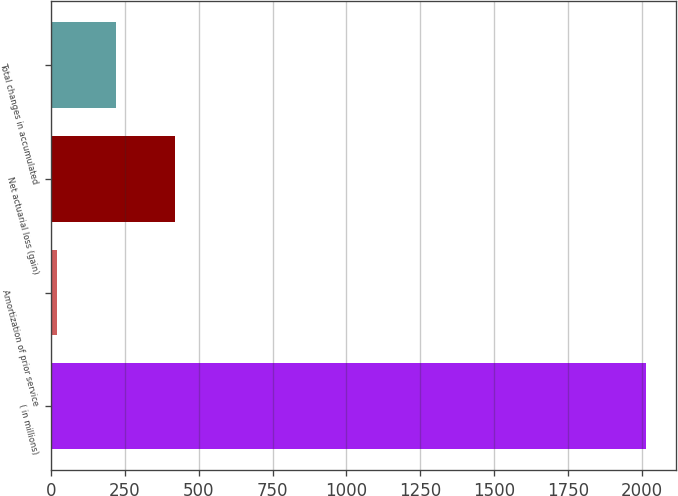Convert chart. <chart><loc_0><loc_0><loc_500><loc_500><bar_chart><fcel>( in millions)<fcel>Amortization of prior service<fcel>Net actuarial loss (gain)<fcel>Total changes in accumulated<nl><fcel>2015<fcel>20<fcel>419<fcel>219.5<nl></chart> 